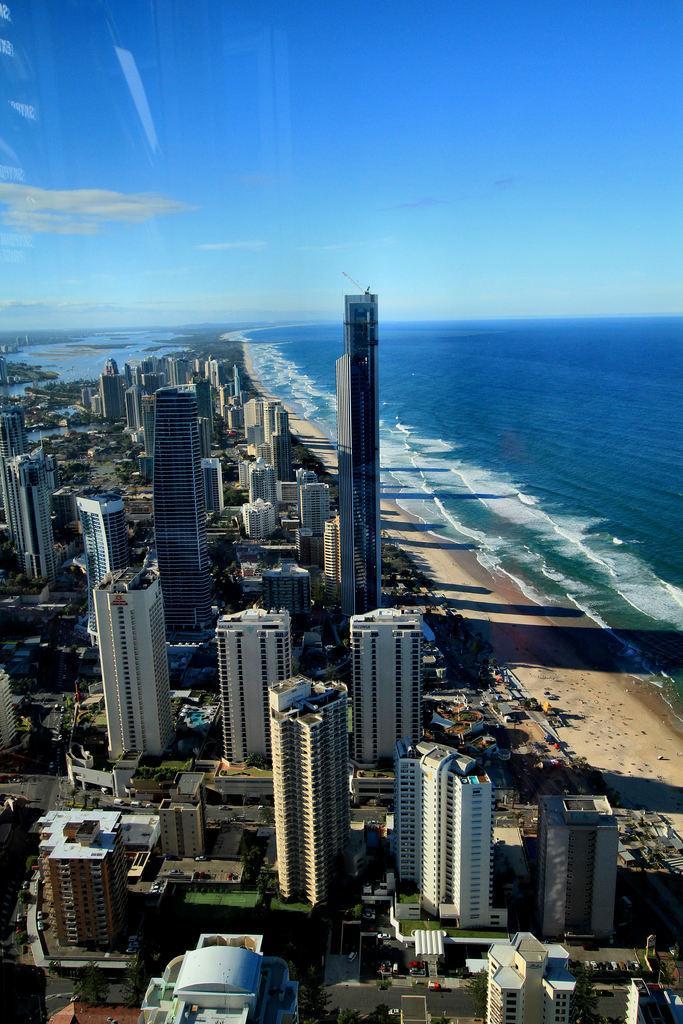How would you summarize this image in a sentence or two? This is a top view of a city, in this image we can see buildings and water. 